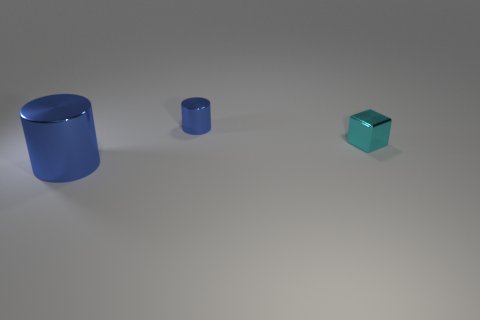Add 2 large purple matte blocks. How many objects exist? 5 Subtract all cylinders. How many objects are left? 1 Add 3 blue cylinders. How many blue cylinders are left? 5 Add 1 cyan cylinders. How many cyan cylinders exist? 1 Subtract 0 purple cylinders. How many objects are left? 3 Subtract all tiny blue metal objects. Subtract all big gray matte balls. How many objects are left? 2 